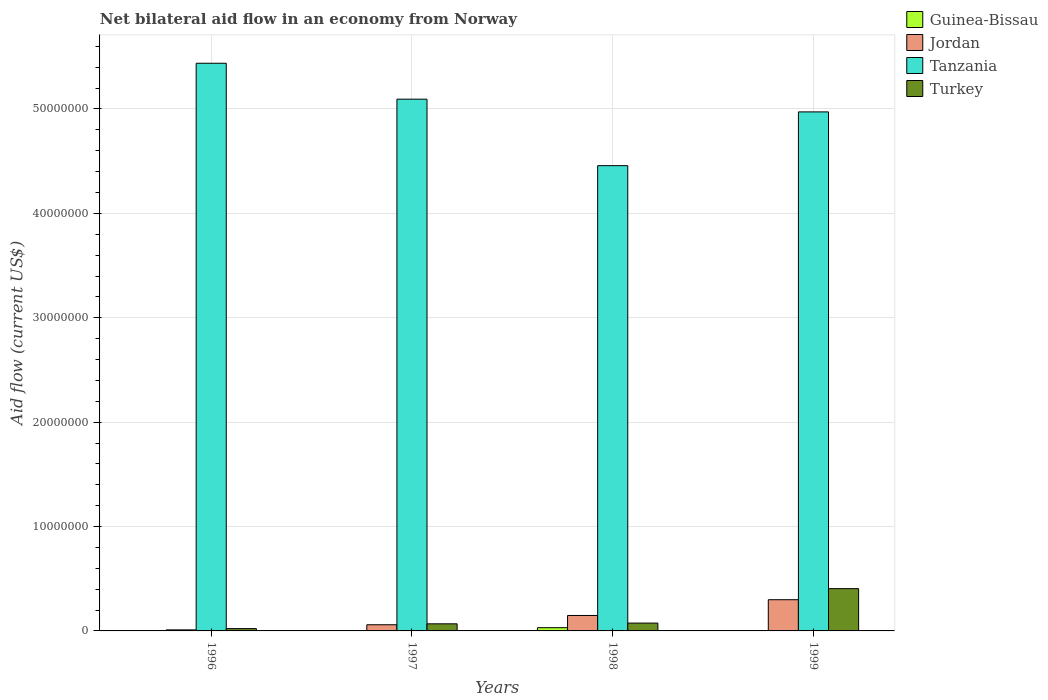How many different coloured bars are there?
Give a very brief answer. 4. How many groups of bars are there?
Your response must be concise. 4. Are the number of bars on each tick of the X-axis equal?
Make the answer very short. Yes. What is the label of the 3rd group of bars from the left?
Your answer should be compact. 1998. What is the net bilateral aid flow in Jordan in 1998?
Offer a very short reply. 1.48e+06. Across all years, what is the maximum net bilateral aid flow in Guinea-Bissau?
Provide a succinct answer. 3.10e+05. Across all years, what is the minimum net bilateral aid flow in Jordan?
Your answer should be compact. 1.00e+05. In which year was the net bilateral aid flow in Jordan maximum?
Keep it short and to the point. 1999. What is the total net bilateral aid flow in Jordan in the graph?
Offer a very short reply. 5.16e+06. What is the difference between the net bilateral aid flow in Tanzania in 1996 and that in 1998?
Your response must be concise. 9.81e+06. What is the difference between the net bilateral aid flow in Jordan in 1996 and the net bilateral aid flow in Turkey in 1999?
Your answer should be compact. -3.95e+06. What is the average net bilateral aid flow in Tanzania per year?
Make the answer very short. 4.99e+07. In the year 1999, what is the difference between the net bilateral aid flow in Tanzania and net bilateral aid flow in Jordan?
Make the answer very short. 4.67e+07. In how many years, is the net bilateral aid flow in Jordan greater than 22000000 US$?
Give a very brief answer. 0. What is the ratio of the net bilateral aid flow in Tanzania in 1996 to that in 1997?
Provide a succinct answer. 1.07. Is the net bilateral aid flow in Jordan in 1997 less than that in 1998?
Make the answer very short. Yes. What is the difference between the highest and the second highest net bilateral aid flow in Turkey?
Provide a succinct answer. 3.30e+06. What is the difference between the highest and the lowest net bilateral aid flow in Guinea-Bissau?
Offer a very short reply. 2.90e+05. In how many years, is the net bilateral aid flow in Turkey greater than the average net bilateral aid flow in Turkey taken over all years?
Give a very brief answer. 1. Is the sum of the net bilateral aid flow in Tanzania in 1997 and 1999 greater than the maximum net bilateral aid flow in Jordan across all years?
Offer a very short reply. Yes. What does the 2nd bar from the left in 1998 represents?
Your answer should be very brief. Jordan. How many bars are there?
Provide a short and direct response. 16. Are all the bars in the graph horizontal?
Offer a very short reply. No. What is the difference between two consecutive major ticks on the Y-axis?
Offer a very short reply. 1.00e+07. What is the title of the graph?
Keep it short and to the point. Net bilateral aid flow in an economy from Norway. What is the label or title of the Y-axis?
Keep it short and to the point. Aid flow (current US$). What is the Aid flow (current US$) of Jordan in 1996?
Your answer should be compact. 1.00e+05. What is the Aid flow (current US$) in Tanzania in 1996?
Offer a terse response. 5.44e+07. What is the Aid flow (current US$) in Turkey in 1996?
Provide a succinct answer. 2.20e+05. What is the Aid flow (current US$) of Jordan in 1997?
Make the answer very short. 5.90e+05. What is the Aid flow (current US$) of Tanzania in 1997?
Your response must be concise. 5.09e+07. What is the Aid flow (current US$) in Turkey in 1997?
Your answer should be compact. 6.80e+05. What is the Aid flow (current US$) in Guinea-Bissau in 1998?
Make the answer very short. 3.10e+05. What is the Aid flow (current US$) in Jordan in 1998?
Offer a terse response. 1.48e+06. What is the Aid flow (current US$) of Tanzania in 1998?
Offer a terse response. 4.46e+07. What is the Aid flow (current US$) of Turkey in 1998?
Ensure brevity in your answer.  7.50e+05. What is the Aid flow (current US$) of Guinea-Bissau in 1999?
Provide a succinct answer. 2.00e+04. What is the Aid flow (current US$) in Jordan in 1999?
Ensure brevity in your answer.  2.99e+06. What is the Aid flow (current US$) in Tanzania in 1999?
Your answer should be compact. 4.97e+07. What is the Aid flow (current US$) in Turkey in 1999?
Provide a succinct answer. 4.05e+06. Across all years, what is the maximum Aid flow (current US$) in Guinea-Bissau?
Your response must be concise. 3.10e+05. Across all years, what is the maximum Aid flow (current US$) of Jordan?
Provide a short and direct response. 2.99e+06. Across all years, what is the maximum Aid flow (current US$) of Tanzania?
Give a very brief answer. 5.44e+07. Across all years, what is the maximum Aid flow (current US$) of Turkey?
Give a very brief answer. 4.05e+06. Across all years, what is the minimum Aid flow (current US$) in Tanzania?
Provide a short and direct response. 4.46e+07. What is the total Aid flow (current US$) in Guinea-Bissau in the graph?
Your answer should be very brief. 3.80e+05. What is the total Aid flow (current US$) in Jordan in the graph?
Keep it short and to the point. 5.16e+06. What is the total Aid flow (current US$) in Tanzania in the graph?
Provide a short and direct response. 2.00e+08. What is the total Aid flow (current US$) in Turkey in the graph?
Offer a terse response. 5.70e+06. What is the difference between the Aid flow (current US$) in Guinea-Bissau in 1996 and that in 1997?
Offer a very short reply. 10000. What is the difference between the Aid flow (current US$) in Jordan in 1996 and that in 1997?
Give a very brief answer. -4.90e+05. What is the difference between the Aid flow (current US$) in Tanzania in 1996 and that in 1997?
Offer a terse response. 3.44e+06. What is the difference between the Aid flow (current US$) in Turkey in 1996 and that in 1997?
Provide a short and direct response. -4.60e+05. What is the difference between the Aid flow (current US$) in Guinea-Bissau in 1996 and that in 1998?
Keep it short and to the point. -2.80e+05. What is the difference between the Aid flow (current US$) in Jordan in 1996 and that in 1998?
Provide a succinct answer. -1.38e+06. What is the difference between the Aid flow (current US$) in Tanzania in 1996 and that in 1998?
Your response must be concise. 9.81e+06. What is the difference between the Aid flow (current US$) in Turkey in 1996 and that in 1998?
Provide a short and direct response. -5.30e+05. What is the difference between the Aid flow (current US$) of Guinea-Bissau in 1996 and that in 1999?
Keep it short and to the point. 10000. What is the difference between the Aid flow (current US$) of Jordan in 1996 and that in 1999?
Make the answer very short. -2.89e+06. What is the difference between the Aid flow (current US$) in Tanzania in 1996 and that in 1999?
Your answer should be compact. 4.66e+06. What is the difference between the Aid flow (current US$) of Turkey in 1996 and that in 1999?
Your response must be concise. -3.83e+06. What is the difference between the Aid flow (current US$) of Jordan in 1997 and that in 1998?
Make the answer very short. -8.90e+05. What is the difference between the Aid flow (current US$) in Tanzania in 1997 and that in 1998?
Your answer should be compact. 6.37e+06. What is the difference between the Aid flow (current US$) in Turkey in 1997 and that in 1998?
Offer a very short reply. -7.00e+04. What is the difference between the Aid flow (current US$) in Guinea-Bissau in 1997 and that in 1999?
Offer a very short reply. 0. What is the difference between the Aid flow (current US$) in Jordan in 1997 and that in 1999?
Make the answer very short. -2.40e+06. What is the difference between the Aid flow (current US$) of Tanzania in 1997 and that in 1999?
Ensure brevity in your answer.  1.22e+06. What is the difference between the Aid flow (current US$) of Turkey in 1997 and that in 1999?
Give a very brief answer. -3.37e+06. What is the difference between the Aid flow (current US$) of Guinea-Bissau in 1998 and that in 1999?
Your answer should be compact. 2.90e+05. What is the difference between the Aid flow (current US$) in Jordan in 1998 and that in 1999?
Your response must be concise. -1.51e+06. What is the difference between the Aid flow (current US$) in Tanzania in 1998 and that in 1999?
Your response must be concise. -5.15e+06. What is the difference between the Aid flow (current US$) in Turkey in 1998 and that in 1999?
Provide a succinct answer. -3.30e+06. What is the difference between the Aid flow (current US$) of Guinea-Bissau in 1996 and the Aid flow (current US$) of Jordan in 1997?
Your response must be concise. -5.60e+05. What is the difference between the Aid flow (current US$) of Guinea-Bissau in 1996 and the Aid flow (current US$) of Tanzania in 1997?
Your answer should be compact. -5.09e+07. What is the difference between the Aid flow (current US$) of Guinea-Bissau in 1996 and the Aid flow (current US$) of Turkey in 1997?
Ensure brevity in your answer.  -6.50e+05. What is the difference between the Aid flow (current US$) in Jordan in 1996 and the Aid flow (current US$) in Tanzania in 1997?
Provide a succinct answer. -5.08e+07. What is the difference between the Aid flow (current US$) in Jordan in 1996 and the Aid flow (current US$) in Turkey in 1997?
Your answer should be very brief. -5.80e+05. What is the difference between the Aid flow (current US$) in Tanzania in 1996 and the Aid flow (current US$) in Turkey in 1997?
Offer a very short reply. 5.37e+07. What is the difference between the Aid flow (current US$) in Guinea-Bissau in 1996 and the Aid flow (current US$) in Jordan in 1998?
Provide a succinct answer. -1.45e+06. What is the difference between the Aid flow (current US$) in Guinea-Bissau in 1996 and the Aid flow (current US$) in Tanzania in 1998?
Provide a short and direct response. -4.45e+07. What is the difference between the Aid flow (current US$) in Guinea-Bissau in 1996 and the Aid flow (current US$) in Turkey in 1998?
Keep it short and to the point. -7.20e+05. What is the difference between the Aid flow (current US$) of Jordan in 1996 and the Aid flow (current US$) of Tanzania in 1998?
Offer a very short reply. -4.45e+07. What is the difference between the Aid flow (current US$) of Jordan in 1996 and the Aid flow (current US$) of Turkey in 1998?
Give a very brief answer. -6.50e+05. What is the difference between the Aid flow (current US$) of Tanzania in 1996 and the Aid flow (current US$) of Turkey in 1998?
Ensure brevity in your answer.  5.36e+07. What is the difference between the Aid flow (current US$) of Guinea-Bissau in 1996 and the Aid flow (current US$) of Jordan in 1999?
Your response must be concise. -2.96e+06. What is the difference between the Aid flow (current US$) in Guinea-Bissau in 1996 and the Aid flow (current US$) in Tanzania in 1999?
Your response must be concise. -4.97e+07. What is the difference between the Aid flow (current US$) in Guinea-Bissau in 1996 and the Aid flow (current US$) in Turkey in 1999?
Your answer should be very brief. -4.02e+06. What is the difference between the Aid flow (current US$) of Jordan in 1996 and the Aid flow (current US$) of Tanzania in 1999?
Your answer should be compact. -4.96e+07. What is the difference between the Aid flow (current US$) in Jordan in 1996 and the Aid flow (current US$) in Turkey in 1999?
Offer a very short reply. -3.95e+06. What is the difference between the Aid flow (current US$) of Tanzania in 1996 and the Aid flow (current US$) of Turkey in 1999?
Ensure brevity in your answer.  5.03e+07. What is the difference between the Aid flow (current US$) of Guinea-Bissau in 1997 and the Aid flow (current US$) of Jordan in 1998?
Keep it short and to the point. -1.46e+06. What is the difference between the Aid flow (current US$) in Guinea-Bissau in 1997 and the Aid flow (current US$) in Tanzania in 1998?
Make the answer very short. -4.46e+07. What is the difference between the Aid flow (current US$) in Guinea-Bissau in 1997 and the Aid flow (current US$) in Turkey in 1998?
Provide a short and direct response. -7.30e+05. What is the difference between the Aid flow (current US$) of Jordan in 1997 and the Aid flow (current US$) of Tanzania in 1998?
Offer a terse response. -4.40e+07. What is the difference between the Aid flow (current US$) in Tanzania in 1997 and the Aid flow (current US$) in Turkey in 1998?
Provide a short and direct response. 5.02e+07. What is the difference between the Aid flow (current US$) in Guinea-Bissau in 1997 and the Aid flow (current US$) in Jordan in 1999?
Provide a succinct answer. -2.97e+06. What is the difference between the Aid flow (current US$) in Guinea-Bissau in 1997 and the Aid flow (current US$) in Tanzania in 1999?
Your answer should be compact. -4.97e+07. What is the difference between the Aid flow (current US$) of Guinea-Bissau in 1997 and the Aid flow (current US$) of Turkey in 1999?
Offer a very short reply. -4.03e+06. What is the difference between the Aid flow (current US$) in Jordan in 1997 and the Aid flow (current US$) in Tanzania in 1999?
Provide a short and direct response. -4.91e+07. What is the difference between the Aid flow (current US$) of Jordan in 1997 and the Aid flow (current US$) of Turkey in 1999?
Make the answer very short. -3.46e+06. What is the difference between the Aid flow (current US$) in Tanzania in 1997 and the Aid flow (current US$) in Turkey in 1999?
Give a very brief answer. 4.69e+07. What is the difference between the Aid flow (current US$) of Guinea-Bissau in 1998 and the Aid flow (current US$) of Jordan in 1999?
Give a very brief answer. -2.68e+06. What is the difference between the Aid flow (current US$) in Guinea-Bissau in 1998 and the Aid flow (current US$) in Tanzania in 1999?
Offer a terse response. -4.94e+07. What is the difference between the Aid flow (current US$) of Guinea-Bissau in 1998 and the Aid flow (current US$) of Turkey in 1999?
Provide a succinct answer. -3.74e+06. What is the difference between the Aid flow (current US$) of Jordan in 1998 and the Aid flow (current US$) of Tanzania in 1999?
Ensure brevity in your answer.  -4.82e+07. What is the difference between the Aid flow (current US$) in Jordan in 1998 and the Aid flow (current US$) in Turkey in 1999?
Keep it short and to the point. -2.57e+06. What is the difference between the Aid flow (current US$) of Tanzania in 1998 and the Aid flow (current US$) of Turkey in 1999?
Your response must be concise. 4.05e+07. What is the average Aid flow (current US$) in Guinea-Bissau per year?
Give a very brief answer. 9.50e+04. What is the average Aid flow (current US$) of Jordan per year?
Offer a very short reply. 1.29e+06. What is the average Aid flow (current US$) of Tanzania per year?
Give a very brief answer. 4.99e+07. What is the average Aid flow (current US$) of Turkey per year?
Provide a short and direct response. 1.42e+06. In the year 1996, what is the difference between the Aid flow (current US$) in Guinea-Bissau and Aid flow (current US$) in Tanzania?
Ensure brevity in your answer.  -5.44e+07. In the year 1996, what is the difference between the Aid flow (current US$) of Jordan and Aid flow (current US$) of Tanzania?
Your response must be concise. -5.43e+07. In the year 1996, what is the difference between the Aid flow (current US$) in Tanzania and Aid flow (current US$) in Turkey?
Offer a terse response. 5.42e+07. In the year 1997, what is the difference between the Aid flow (current US$) in Guinea-Bissau and Aid flow (current US$) in Jordan?
Provide a succinct answer. -5.70e+05. In the year 1997, what is the difference between the Aid flow (current US$) of Guinea-Bissau and Aid flow (current US$) of Tanzania?
Your answer should be compact. -5.09e+07. In the year 1997, what is the difference between the Aid flow (current US$) of Guinea-Bissau and Aid flow (current US$) of Turkey?
Ensure brevity in your answer.  -6.60e+05. In the year 1997, what is the difference between the Aid flow (current US$) of Jordan and Aid flow (current US$) of Tanzania?
Your answer should be compact. -5.04e+07. In the year 1997, what is the difference between the Aid flow (current US$) in Jordan and Aid flow (current US$) in Turkey?
Your response must be concise. -9.00e+04. In the year 1997, what is the difference between the Aid flow (current US$) in Tanzania and Aid flow (current US$) in Turkey?
Offer a very short reply. 5.03e+07. In the year 1998, what is the difference between the Aid flow (current US$) in Guinea-Bissau and Aid flow (current US$) in Jordan?
Give a very brief answer. -1.17e+06. In the year 1998, what is the difference between the Aid flow (current US$) of Guinea-Bissau and Aid flow (current US$) of Tanzania?
Ensure brevity in your answer.  -4.43e+07. In the year 1998, what is the difference between the Aid flow (current US$) of Guinea-Bissau and Aid flow (current US$) of Turkey?
Provide a succinct answer. -4.40e+05. In the year 1998, what is the difference between the Aid flow (current US$) of Jordan and Aid flow (current US$) of Tanzania?
Your answer should be compact. -4.31e+07. In the year 1998, what is the difference between the Aid flow (current US$) of Jordan and Aid flow (current US$) of Turkey?
Ensure brevity in your answer.  7.30e+05. In the year 1998, what is the difference between the Aid flow (current US$) of Tanzania and Aid flow (current US$) of Turkey?
Offer a terse response. 4.38e+07. In the year 1999, what is the difference between the Aid flow (current US$) in Guinea-Bissau and Aid flow (current US$) in Jordan?
Provide a short and direct response. -2.97e+06. In the year 1999, what is the difference between the Aid flow (current US$) of Guinea-Bissau and Aid flow (current US$) of Tanzania?
Ensure brevity in your answer.  -4.97e+07. In the year 1999, what is the difference between the Aid flow (current US$) of Guinea-Bissau and Aid flow (current US$) of Turkey?
Your response must be concise. -4.03e+06. In the year 1999, what is the difference between the Aid flow (current US$) in Jordan and Aid flow (current US$) in Tanzania?
Your answer should be compact. -4.67e+07. In the year 1999, what is the difference between the Aid flow (current US$) in Jordan and Aid flow (current US$) in Turkey?
Your answer should be compact. -1.06e+06. In the year 1999, what is the difference between the Aid flow (current US$) in Tanzania and Aid flow (current US$) in Turkey?
Provide a succinct answer. 4.57e+07. What is the ratio of the Aid flow (current US$) in Jordan in 1996 to that in 1997?
Provide a short and direct response. 0.17. What is the ratio of the Aid flow (current US$) in Tanzania in 1996 to that in 1997?
Make the answer very short. 1.07. What is the ratio of the Aid flow (current US$) of Turkey in 1996 to that in 1997?
Ensure brevity in your answer.  0.32. What is the ratio of the Aid flow (current US$) of Guinea-Bissau in 1996 to that in 1998?
Your answer should be very brief. 0.1. What is the ratio of the Aid flow (current US$) in Jordan in 1996 to that in 1998?
Your response must be concise. 0.07. What is the ratio of the Aid flow (current US$) of Tanzania in 1996 to that in 1998?
Keep it short and to the point. 1.22. What is the ratio of the Aid flow (current US$) in Turkey in 1996 to that in 1998?
Offer a very short reply. 0.29. What is the ratio of the Aid flow (current US$) of Guinea-Bissau in 1996 to that in 1999?
Keep it short and to the point. 1.5. What is the ratio of the Aid flow (current US$) of Jordan in 1996 to that in 1999?
Your response must be concise. 0.03. What is the ratio of the Aid flow (current US$) of Tanzania in 1996 to that in 1999?
Ensure brevity in your answer.  1.09. What is the ratio of the Aid flow (current US$) in Turkey in 1996 to that in 1999?
Your response must be concise. 0.05. What is the ratio of the Aid flow (current US$) in Guinea-Bissau in 1997 to that in 1998?
Ensure brevity in your answer.  0.06. What is the ratio of the Aid flow (current US$) in Jordan in 1997 to that in 1998?
Offer a terse response. 0.4. What is the ratio of the Aid flow (current US$) of Tanzania in 1997 to that in 1998?
Offer a very short reply. 1.14. What is the ratio of the Aid flow (current US$) in Turkey in 1997 to that in 1998?
Provide a short and direct response. 0.91. What is the ratio of the Aid flow (current US$) of Jordan in 1997 to that in 1999?
Your answer should be very brief. 0.2. What is the ratio of the Aid flow (current US$) of Tanzania in 1997 to that in 1999?
Provide a short and direct response. 1.02. What is the ratio of the Aid flow (current US$) in Turkey in 1997 to that in 1999?
Your answer should be compact. 0.17. What is the ratio of the Aid flow (current US$) of Guinea-Bissau in 1998 to that in 1999?
Your answer should be compact. 15.5. What is the ratio of the Aid flow (current US$) in Jordan in 1998 to that in 1999?
Provide a succinct answer. 0.49. What is the ratio of the Aid flow (current US$) in Tanzania in 1998 to that in 1999?
Offer a very short reply. 0.9. What is the ratio of the Aid flow (current US$) in Turkey in 1998 to that in 1999?
Your answer should be very brief. 0.19. What is the difference between the highest and the second highest Aid flow (current US$) in Jordan?
Provide a short and direct response. 1.51e+06. What is the difference between the highest and the second highest Aid flow (current US$) in Tanzania?
Give a very brief answer. 3.44e+06. What is the difference between the highest and the second highest Aid flow (current US$) of Turkey?
Give a very brief answer. 3.30e+06. What is the difference between the highest and the lowest Aid flow (current US$) in Guinea-Bissau?
Keep it short and to the point. 2.90e+05. What is the difference between the highest and the lowest Aid flow (current US$) in Jordan?
Make the answer very short. 2.89e+06. What is the difference between the highest and the lowest Aid flow (current US$) of Tanzania?
Offer a terse response. 9.81e+06. What is the difference between the highest and the lowest Aid flow (current US$) in Turkey?
Your answer should be very brief. 3.83e+06. 